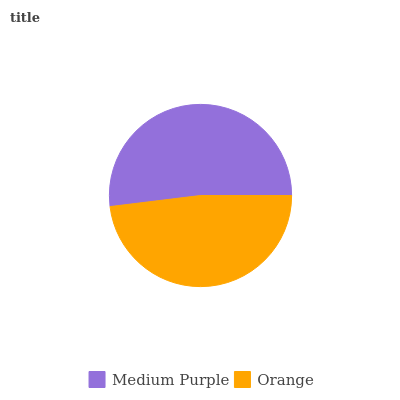Is Orange the minimum?
Answer yes or no. Yes. Is Medium Purple the maximum?
Answer yes or no. Yes. Is Orange the maximum?
Answer yes or no. No. Is Medium Purple greater than Orange?
Answer yes or no. Yes. Is Orange less than Medium Purple?
Answer yes or no. Yes. Is Orange greater than Medium Purple?
Answer yes or no. No. Is Medium Purple less than Orange?
Answer yes or no. No. Is Medium Purple the high median?
Answer yes or no. Yes. Is Orange the low median?
Answer yes or no. Yes. Is Orange the high median?
Answer yes or no. No. Is Medium Purple the low median?
Answer yes or no. No. 